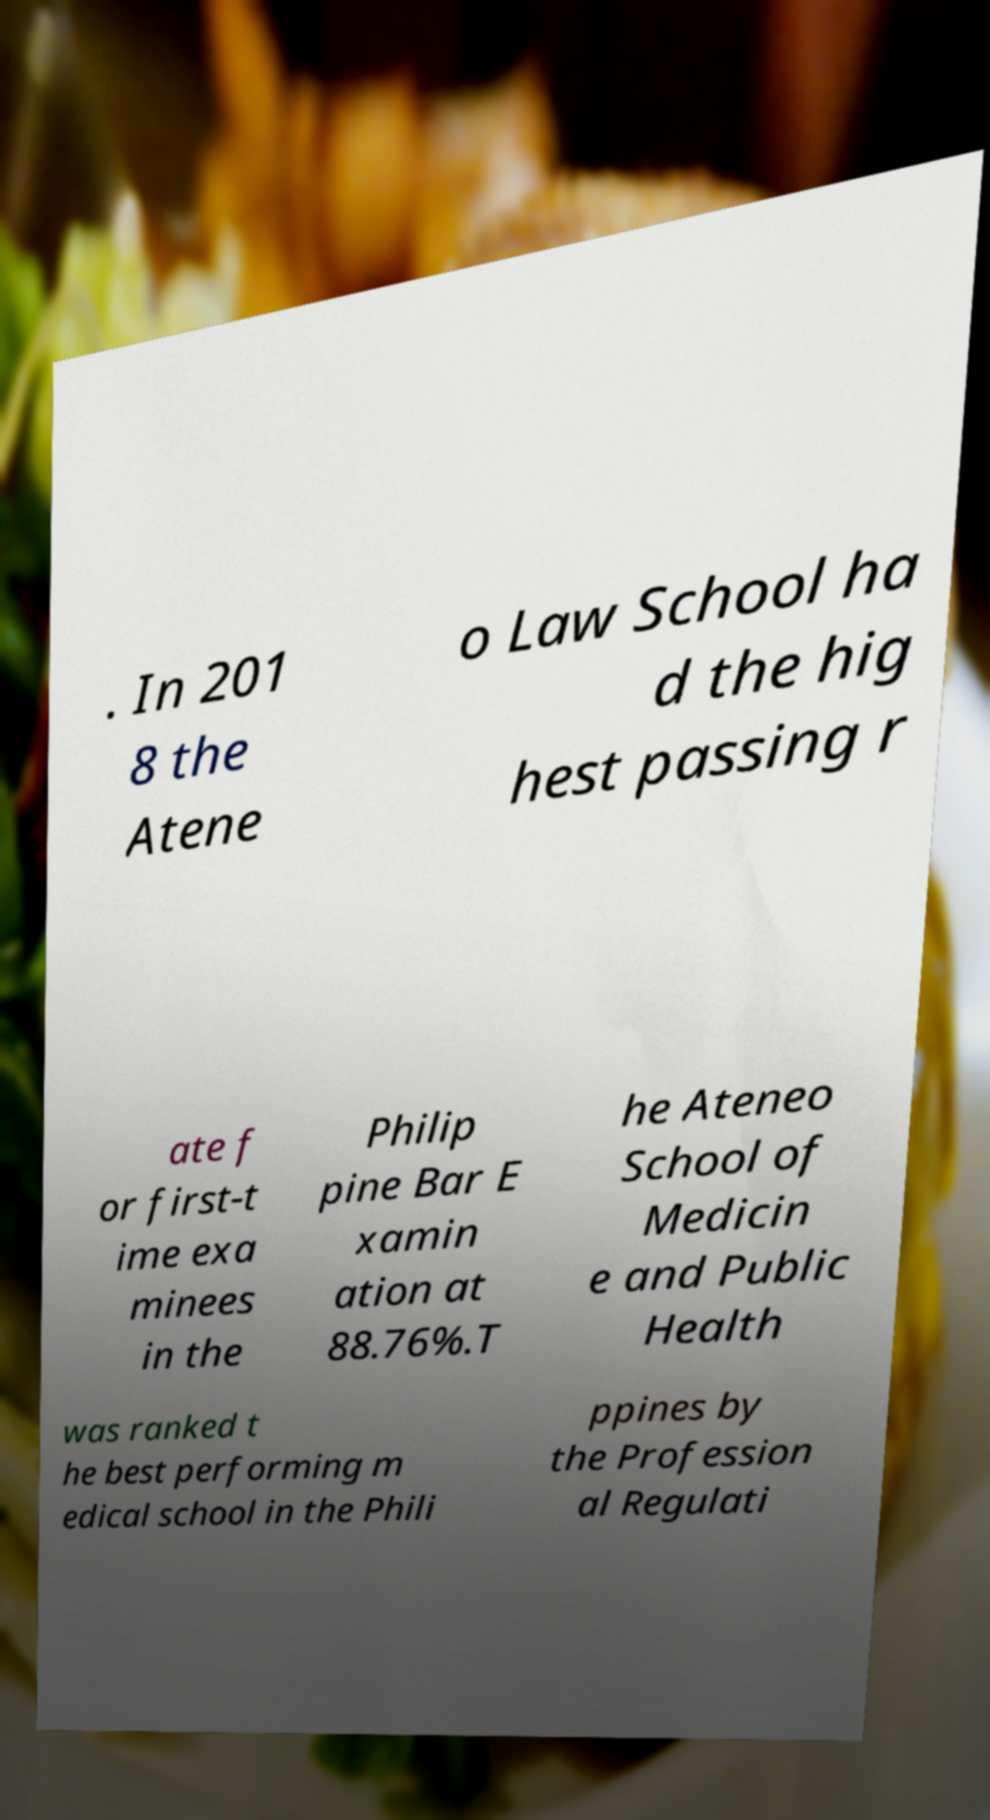Please identify and transcribe the text found in this image. . In 201 8 the Atene o Law School ha d the hig hest passing r ate f or first-t ime exa minees in the Philip pine Bar E xamin ation at 88.76%.T he Ateneo School of Medicin e and Public Health was ranked t he best performing m edical school in the Phili ppines by the Profession al Regulati 